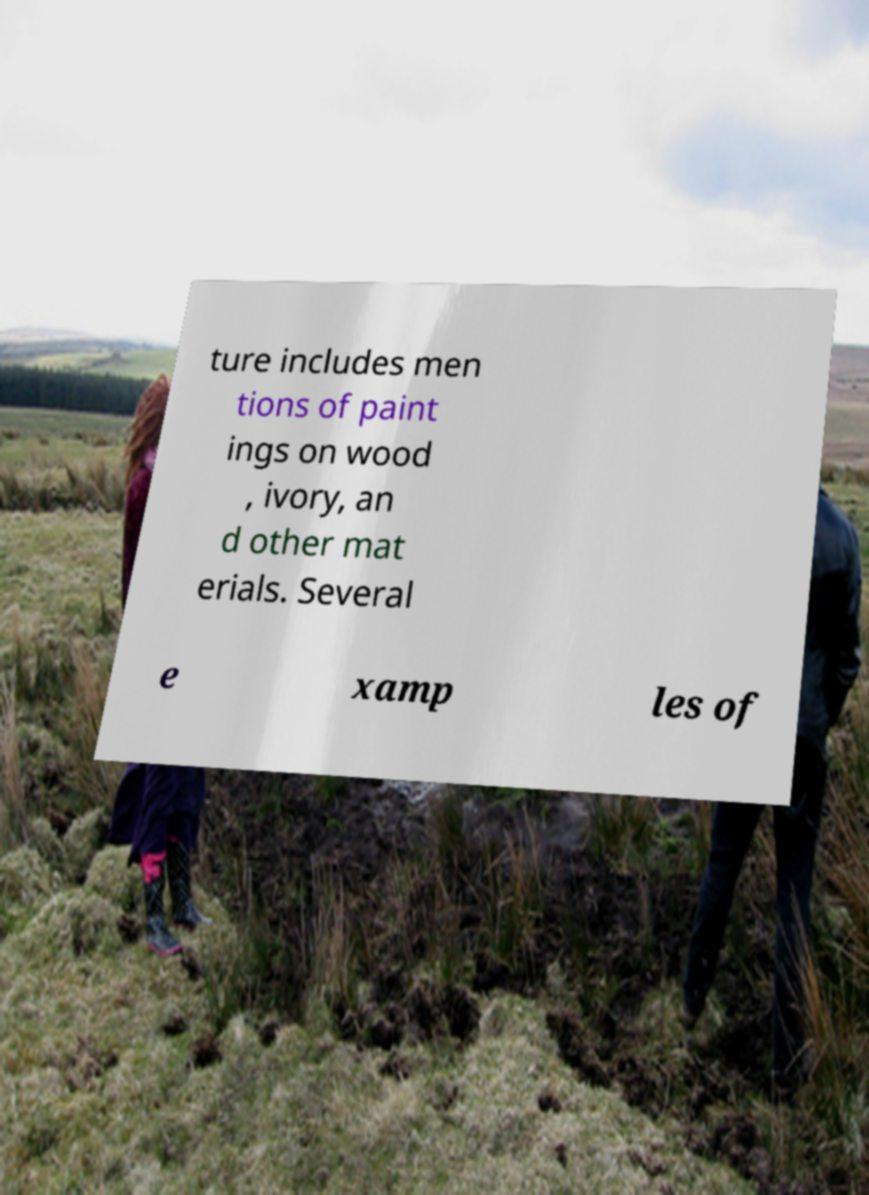What messages or text are displayed in this image? I need them in a readable, typed format. ture includes men tions of paint ings on wood , ivory, an d other mat erials. Several e xamp les of 